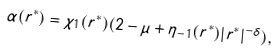<formula> <loc_0><loc_0><loc_500><loc_500>\alpha ( r ^ { * } ) = \chi _ { 1 } ( r ^ { * } ) ( 2 - \mu + \eta _ { - 1 } ( r ^ { * } ) | r ^ { * } | ^ { - \delta } ) ,</formula> 